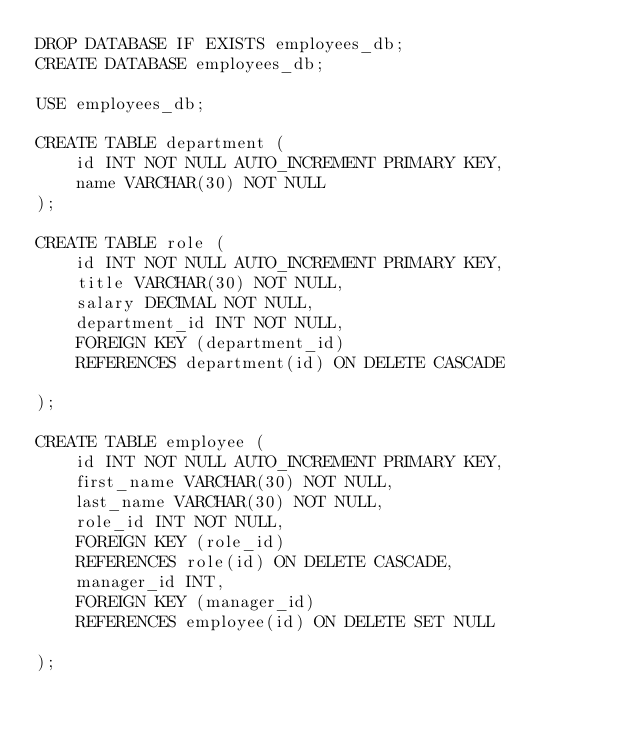<code> <loc_0><loc_0><loc_500><loc_500><_SQL_>DROP DATABASE IF EXISTS employees_db;
CREATE DATABASE employees_db;

USE employees_db;

CREATE TABLE department (
    id INT NOT NULL AUTO_INCREMENT PRIMARY KEY,
    name VARCHAR(30) NOT NULL
);

CREATE TABLE role (
    id INT NOT NULL AUTO_INCREMENT PRIMARY KEY,
    title VARCHAR(30) NOT NULL,
    salary DECIMAL NOT NULL,
    department_id INT NOT NULL,
    FOREIGN KEY (department_id) 
    REFERENCES department(id) ON DELETE CASCADE

);

CREATE TABLE employee (
    id INT NOT NULL AUTO_INCREMENT PRIMARY KEY,
    first_name VARCHAR(30) NOT NULL,
    last_name VARCHAR(30) NOT NULL,
    role_id INT NOT NULL,
    FOREIGN KEY (role_id) 
    REFERENCES role(id) ON DELETE CASCADE,
    manager_id INT,
    FOREIGN KEY (manager_id)
    REFERENCES employee(id) ON DELETE SET NULL

);
</code> 